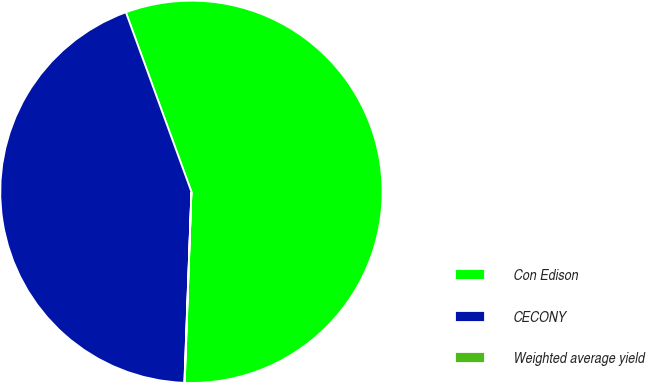Convert chart. <chart><loc_0><loc_0><loc_500><loc_500><pie_chart><fcel>Con Edison<fcel>CECONY<fcel>Weighted average yield<nl><fcel>56.13%<fcel>43.84%<fcel>0.03%<nl></chart> 